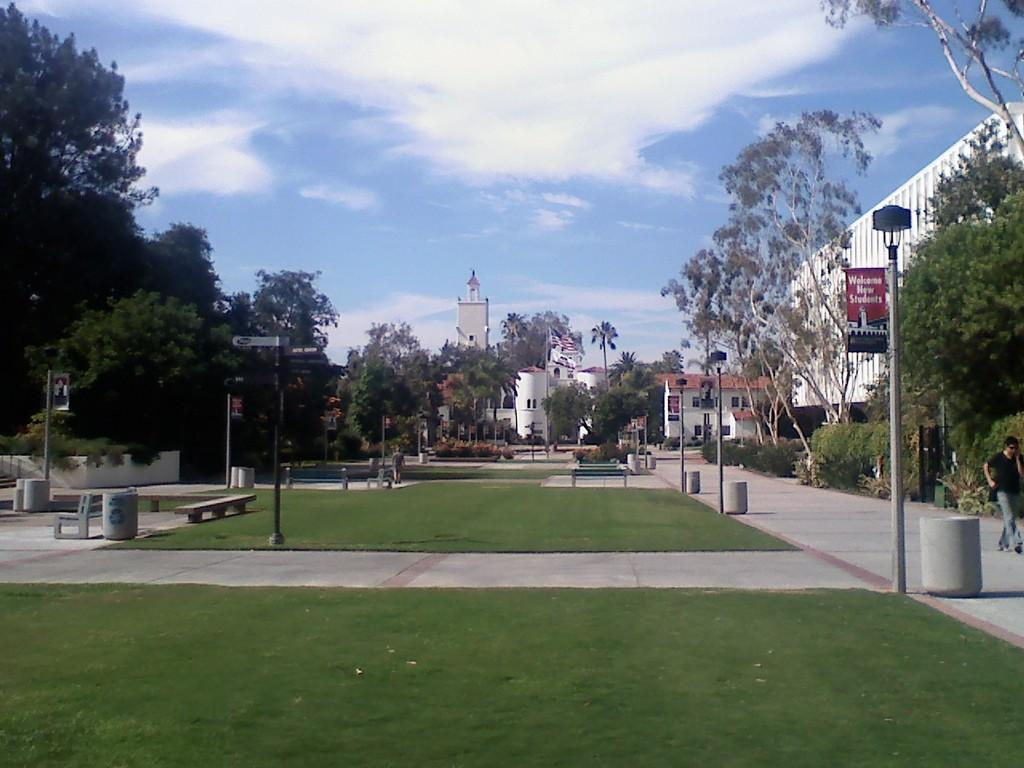What type of landscape is visible at the bottom of the image? There is grassland at the bottom side of the image. What can be seen in the center of the image? There are trees and houses in the center of the image. How many dogs can be seen playing with the houses in the image? There are no dogs present in the image; it features grassland, trees, and houses. 